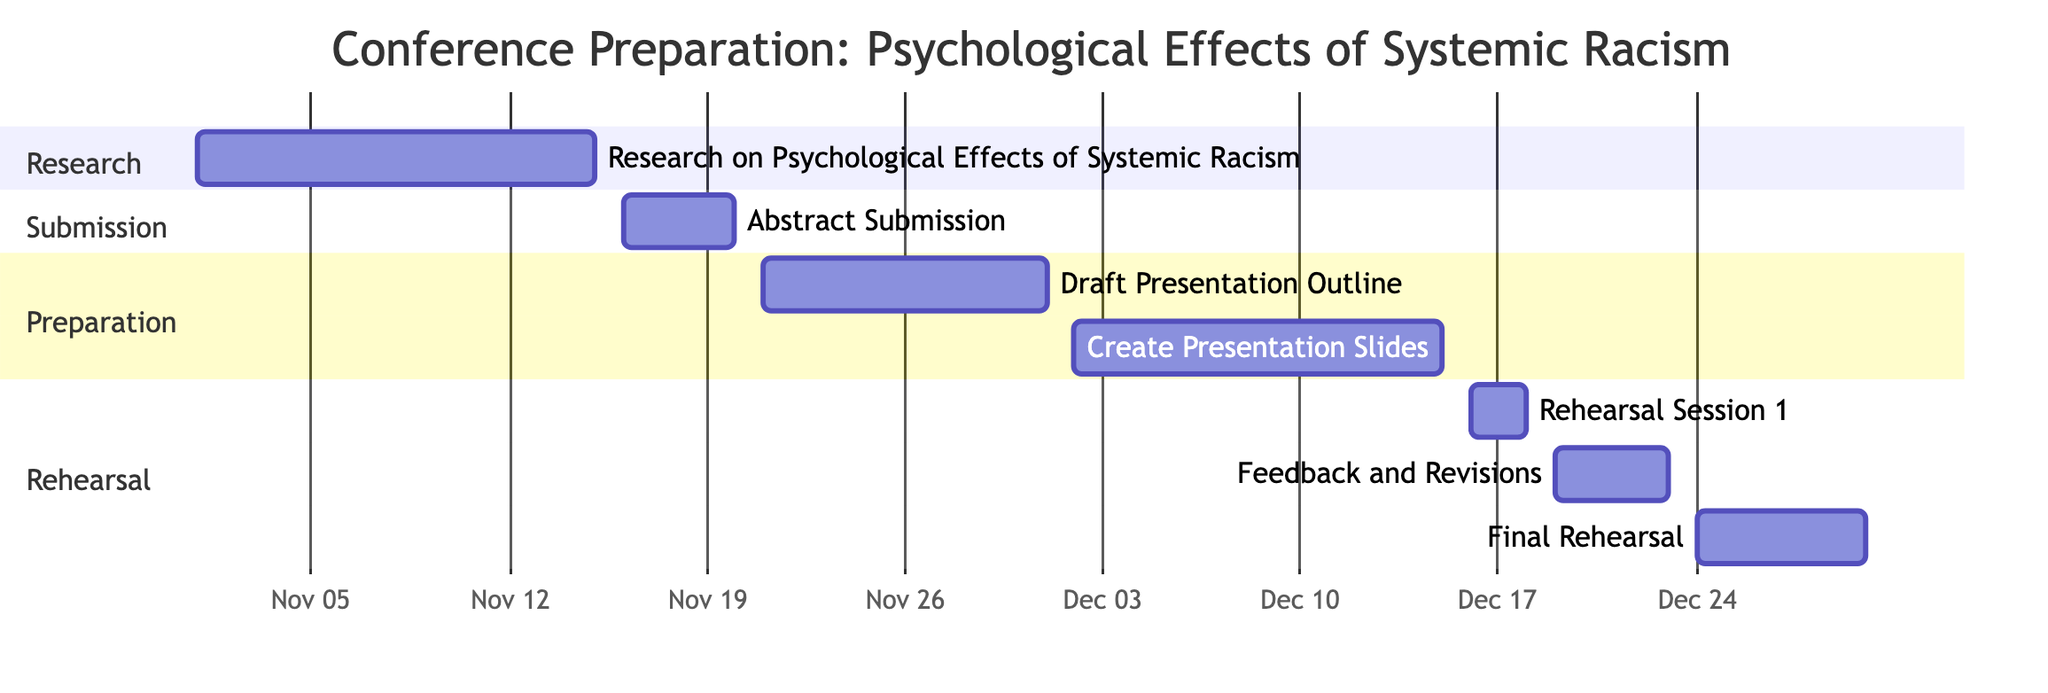What is the start date for the "Abstract Submission"? The "Abstract Submission" task starts on November 16, 2023, as indicated in the diagram under the Submission section.
Answer: November 16, 2023 How many days are allocated for "Rehearsal Session 1"? "Rehearsal Session 1" is scheduled from December 16, 2023, to December 18, 2023, which is a total of 3 days.
Answer: 3 days Which task comes immediately after "Draft Presentation Outline"? The task that follows "Draft Presentation Outline" is "Create Presentation Slides," according to the sequential order of tasks shown in the diagram.
Answer: Create Presentation Slides What is the total number of tasks listed in the Gantt chart? There are seven tasks shown in the Gantt chart, including Research, Submission, Preparation, and Rehearsal tasks.
Answer: 7 What is the end date for the "Final Rehearsal"? The "Final Rehearsal" task concludes on December 30, 2023, as specified in the diagram.
Answer: December 30, 2023 How many tasks are in the "Rehearsal" section? There are three tasks listed in the "Rehearsal" section: "Rehearsal Session 1," "Feedback and Revisions," and "Final Rehearsal."
Answer: 3 tasks What is the duration of the "Feedback and Revisions" task? The "Feedback and Revisions" task runs from December 19, 2023, to December 23, 2023, which totals 5 days.
Answer: 5 days Which task begins immediately after the "Create Presentation Slides"? The task that starts immediately after "Create Presentation Slides" is "Rehearsal Session 1." This is seen clearly as a continuation in the schedule flow.
Answer: Rehearsal Session 1 